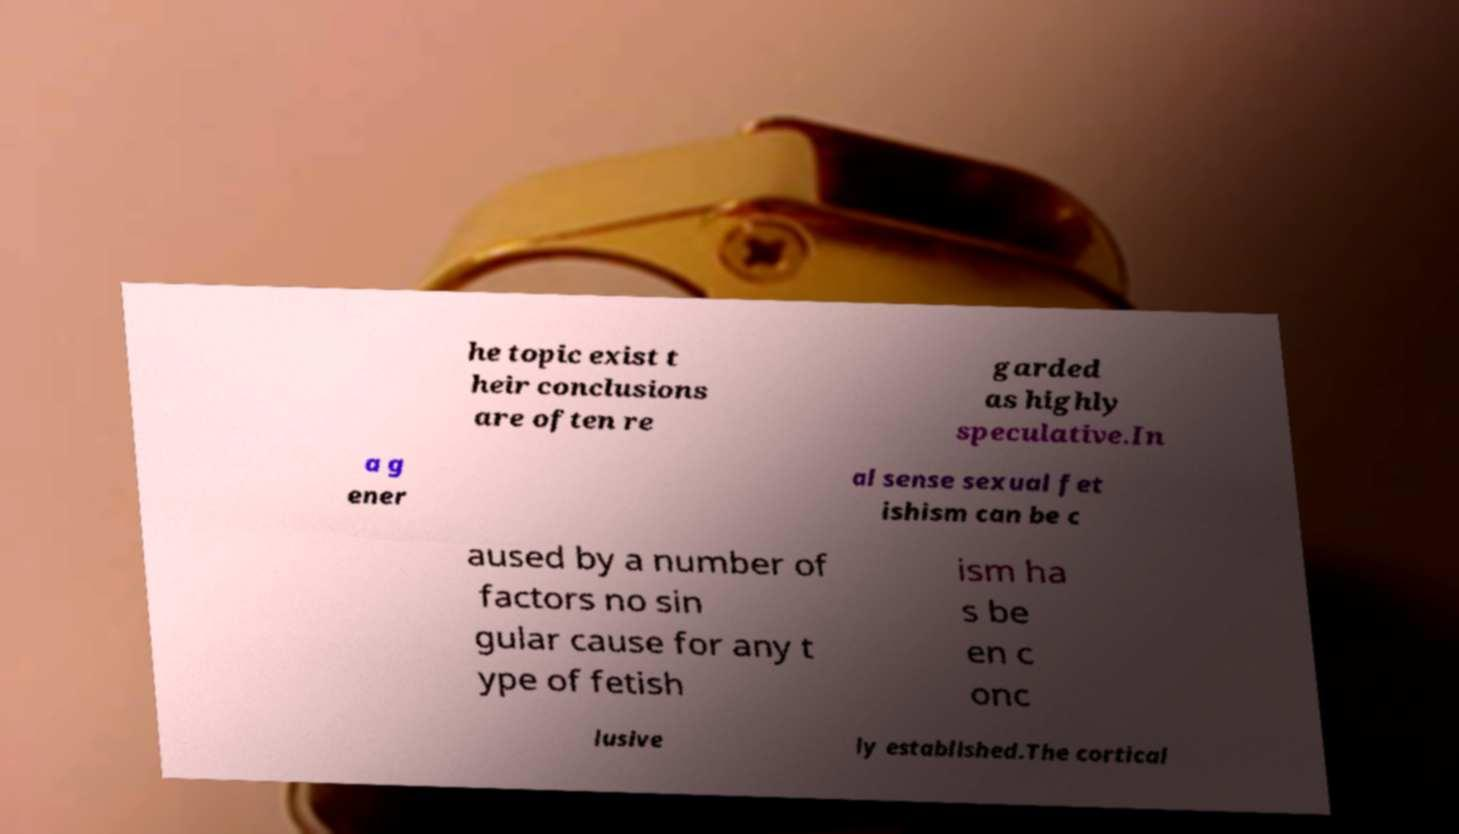Can you accurately transcribe the text from the provided image for me? he topic exist t heir conclusions are often re garded as highly speculative.In a g ener al sense sexual fet ishism can be c aused by a number of factors no sin gular cause for any t ype of fetish ism ha s be en c onc lusive ly established.The cortical 